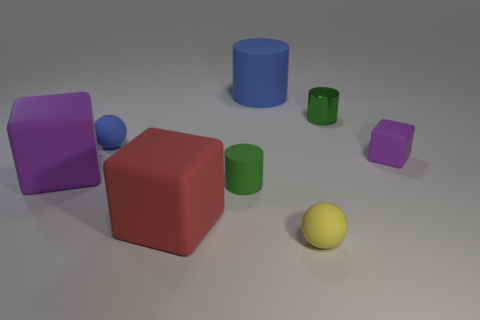What number of other objects are the same color as the tiny metal cylinder?
Offer a very short reply. 1. Are the big block that is to the right of the blue sphere and the purple block to the right of the green matte cylinder made of the same material?
Offer a terse response. Yes. How big is the purple block left of the tiny yellow matte object?
Ensure brevity in your answer.  Large. There is a big purple object that is the same shape as the tiny purple rubber object; what is it made of?
Your response must be concise. Rubber. What is the shape of the tiny rubber thing that is on the right side of the tiny yellow rubber thing?
Provide a short and direct response. Cube. What number of other matte things have the same shape as the large blue thing?
Your answer should be compact. 1. Are there the same number of green objects that are in front of the metal cylinder and green metallic objects in front of the large purple rubber object?
Your response must be concise. No. Is there a small cube made of the same material as the tiny yellow sphere?
Provide a short and direct response. Yes. Is the material of the blue cylinder the same as the small cube?
Offer a very short reply. Yes. How many red objects are cylinders or blocks?
Give a very brief answer. 1. 